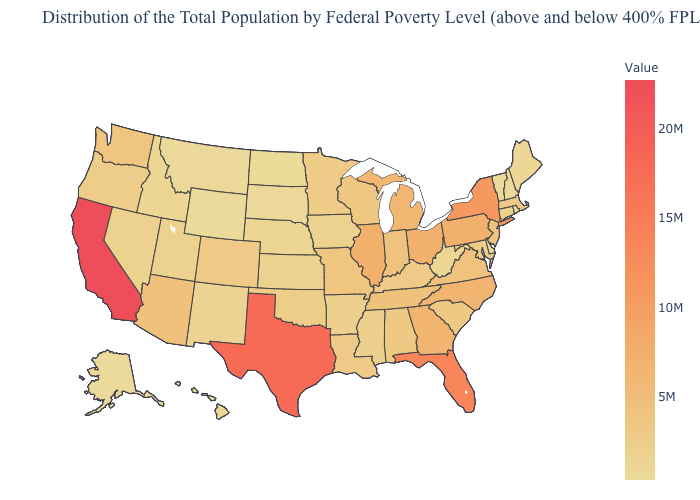Which states have the lowest value in the USA?
Concise answer only. Wyoming. Which states have the lowest value in the USA?
Give a very brief answer. Wyoming. Does Hawaii have the highest value in the USA?
Write a very short answer. No. Which states have the highest value in the USA?
Quick response, please. California. Which states have the highest value in the USA?
Keep it brief. California. Which states hav the highest value in the South?
Short answer required. Texas. Which states hav the highest value in the South?
Short answer required. Texas. 